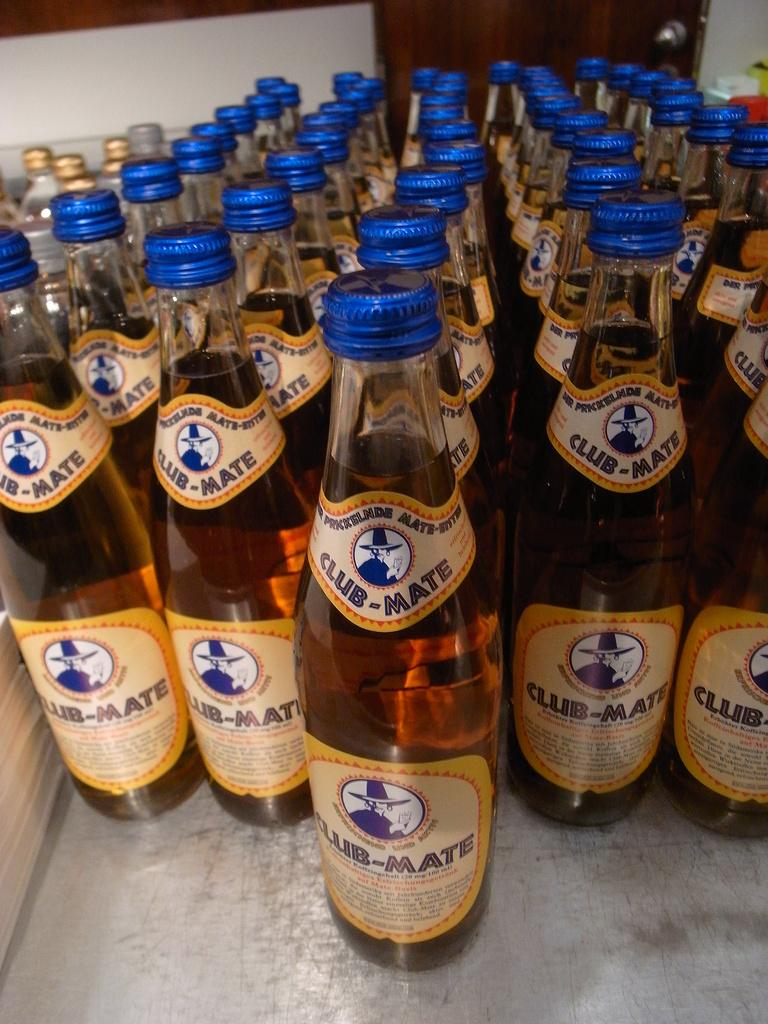<image>
Describe the image concisely. Rows of Club-Mate beverages with a yellow label and blue cap. 